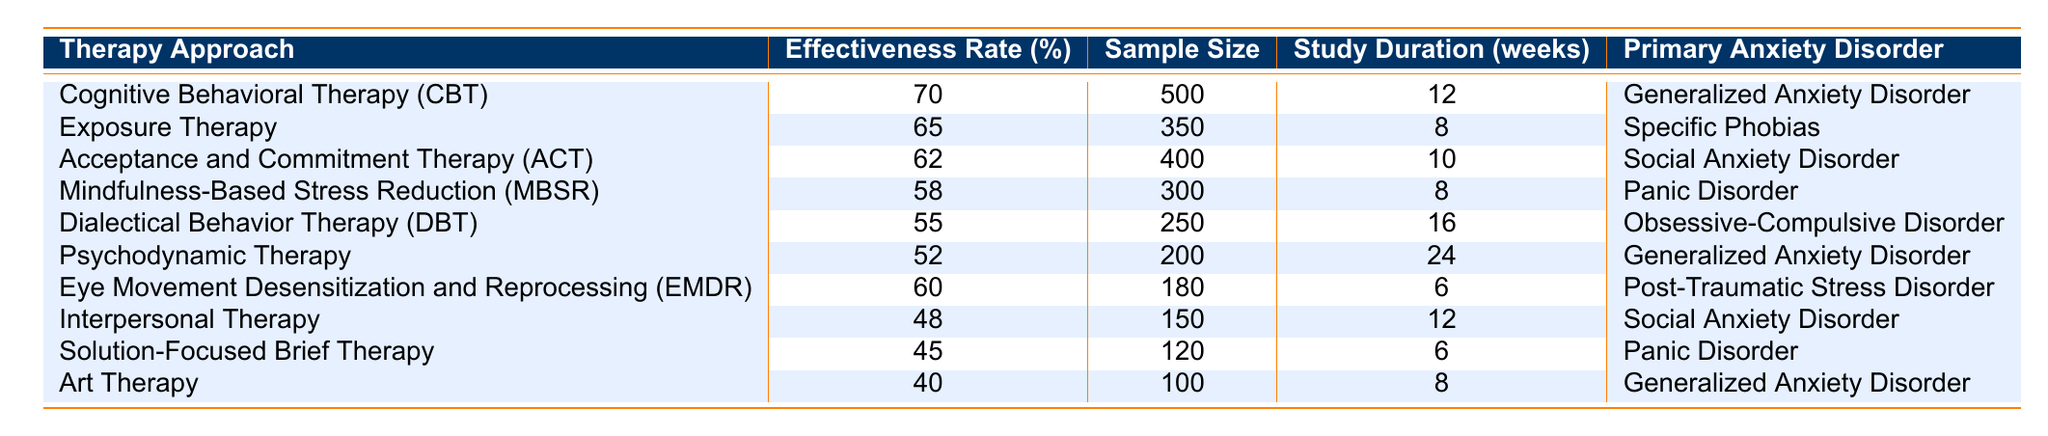What is the effectiveness rate of Cognitive Behavioral Therapy (CBT)? The table shows that the effectiveness rate of CBT is listed under the 'Effectiveness Rate (%)' column for the corresponding therapy approach. According to the table, it is 70%.
Answer: 70% Which therapy approach has the lowest effectiveness rate? By examining the 'Effectiveness Rate (%)' column, we find Art Therapy has the lowest effectiveness rate at 40%.
Answer: 40% How many participants were involved in the study for Acceptance and Commitment Therapy (ACT)? The sample size for ACT is found in the 'Sample Size' column. According to the table, it states 400 participants participated in the study for ACT.
Answer: 400 What is the duration of the study for Dialectical Behavior Therapy (DBT)? The duration is noted in the 'Study Duration (weeks)' column. For DBT, the table indicates that the study lasted 16 weeks.
Answer: 16 weeks Is the effectiveness rate of Exposure Therapy greater than that of Mindfulness-Based Stress Reduction (MBSR)? We look at the effectiveness rates for both therapies: Exposure Therapy is 65% and MBSR is 58%. Since 65% is greater than 58%, the answer is yes.
Answer: Yes What is the average effectiveness rate of all therapy approaches listed in the table? To find the average, sum the effectiveness rates: (70 + 65 + 62 + 58 + 55 + 52 + 60 + 48 + 45 + 40) = 615. There are 10 therapy approaches: 615/10 = 61.5.
Answer: 61.5 Is it true that all therapies listed target a specific anxiety disorder? The table indicates that various therapy approaches target different primary anxiety disorders, like GAD, Social Anxiety Disorder, etc. Therefore, the statement is true.
Answer: True What percentage difference in effectiveness rate exists between Cognitive Behavioral Therapy (CBT) and Psychodynamic Therapy? The effectiveness rate of CBT is 70% and Psychodynamic Therapy is 52%. The difference is: 70 - 52 = 18%.
Answer: 18% How many therapy approaches have an effectiveness rate of 60% or higher? By reviewing the effectiveness rates: CBT (70%), Exposure Therapy (65%), ACT (62%), and EMDR (60%), we count 4 therapies.
Answer: 4 Which therapy has the highest effectiveness rate for Generalized Anxiety Disorder? Looking at the 'Primary Anxiety Disorder' column, CBT has the highest effectiveness rate of 70% for Generalized Anxiety Disorder, compared to Psychodynamic Therapy's 52% and Art Therapy's 40%.
Answer: CBT with 70% 